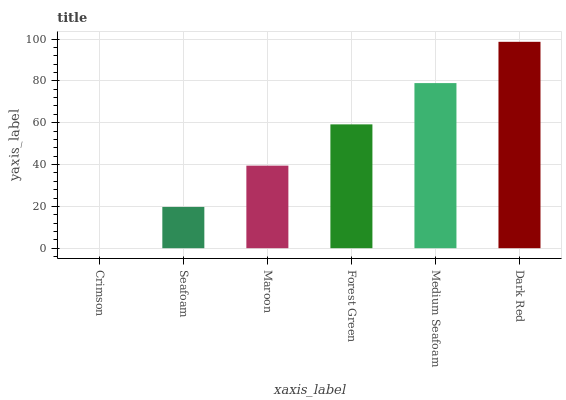Is Seafoam the minimum?
Answer yes or no. No. Is Seafoam the maximum?
Answer yes or no. No. Is Seafoam greater than Crimson?
Answer yes or no. Yes. Is Crimson less than Seafoam?
Answer yes or no. Yes. Is Crimson greater than Seafoam?
Answer yes or no. No. Is Seafoam less than Crimson?
Answer yes or no. No. Is Forest Green the high median?
Answer yes or no. Yes. Is Maroon the low median?
Answer yes or no. Yes. Is Crimson the high median?
Answer yes or no. No. Is Crimson the low median?
Answer yes or no. No. 